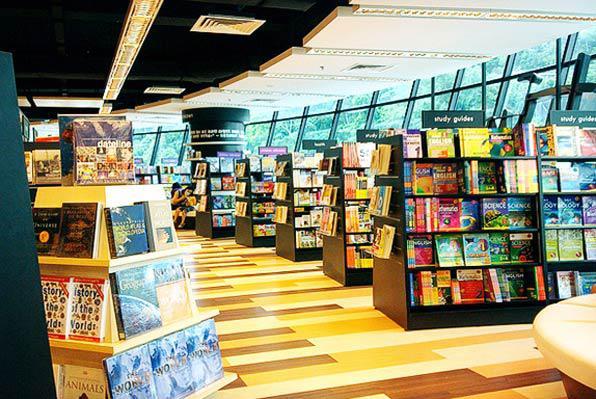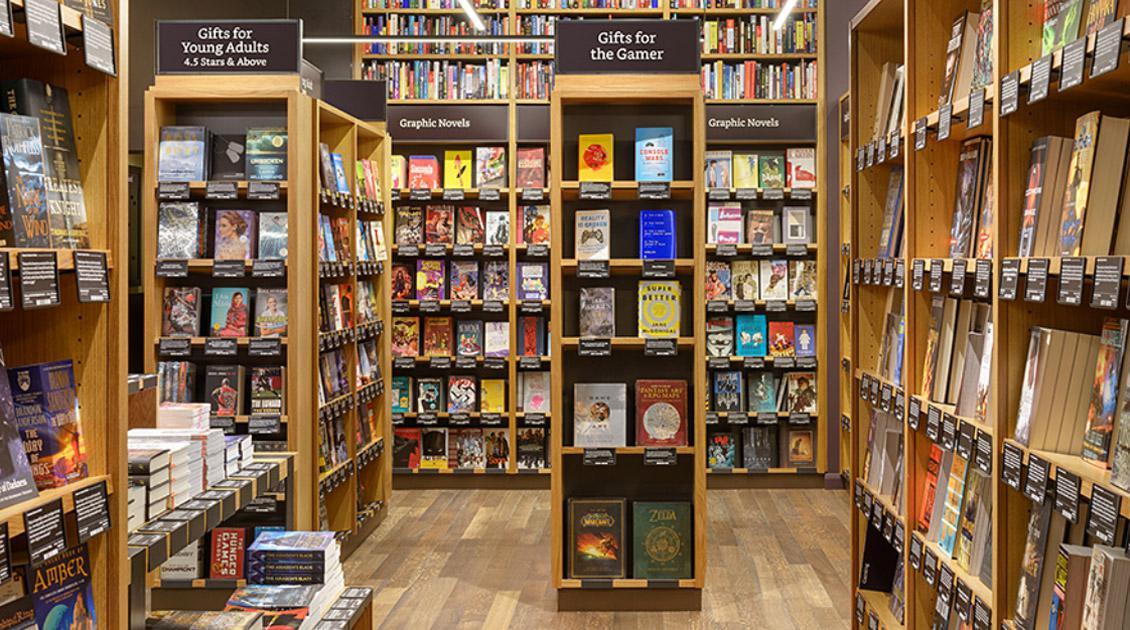The first image is the image on the left, the second image is the image on the right. Assess this claim about the two images: "The right image shows the exterior of a bookshop.". Correct or not? Answer yes or no. No. The first image is the image on the left, the second image is the image on the right. For the images shown, is this caption "One image is the interior of a bookshop and one image is the exterior of a bookshop." true? Answer yes or no. No. 